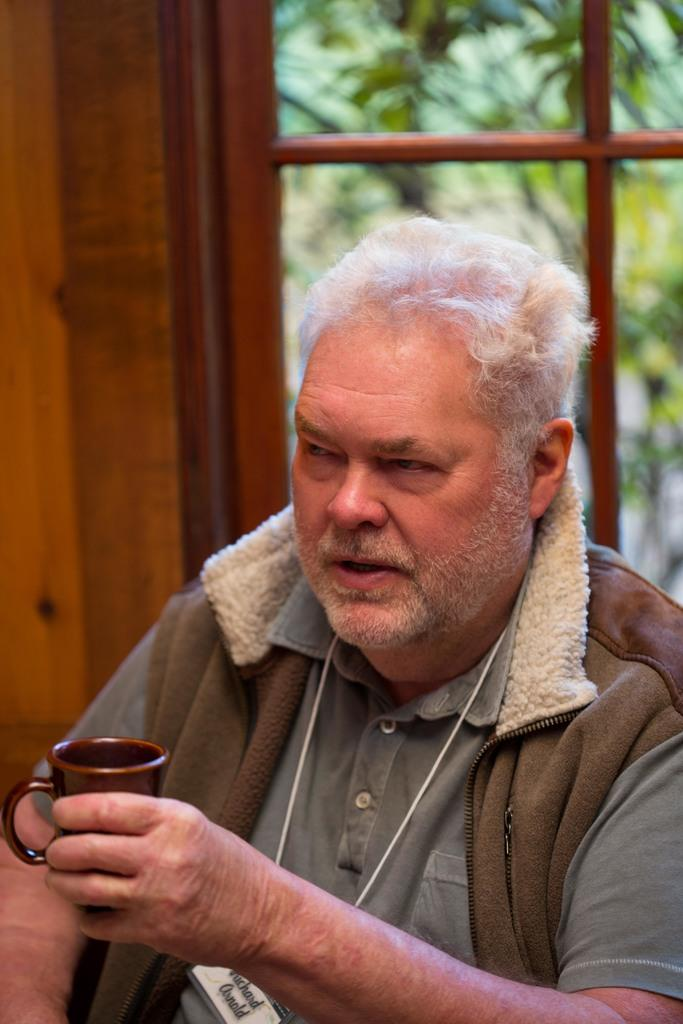Who is present in the image? There is a man in the image. What is the man wearing? The man is wearing a brown jacket and a green t-shirt. What is the man holding in his hand? The man is holding a cup in his hand. What can be seen behind the man? There is a window behind the man, and a tree is visible outside the window. What type of wall is on the left side of the image? There is a wooden wall to the left side of the image. What is the man's mom doing in the image? There is no mention of the man's mom in the image, so we cannot answer that question. Is the man swimming in the image? There is no indication of swimming in the image; the man is holding a cup and standing near a window. 